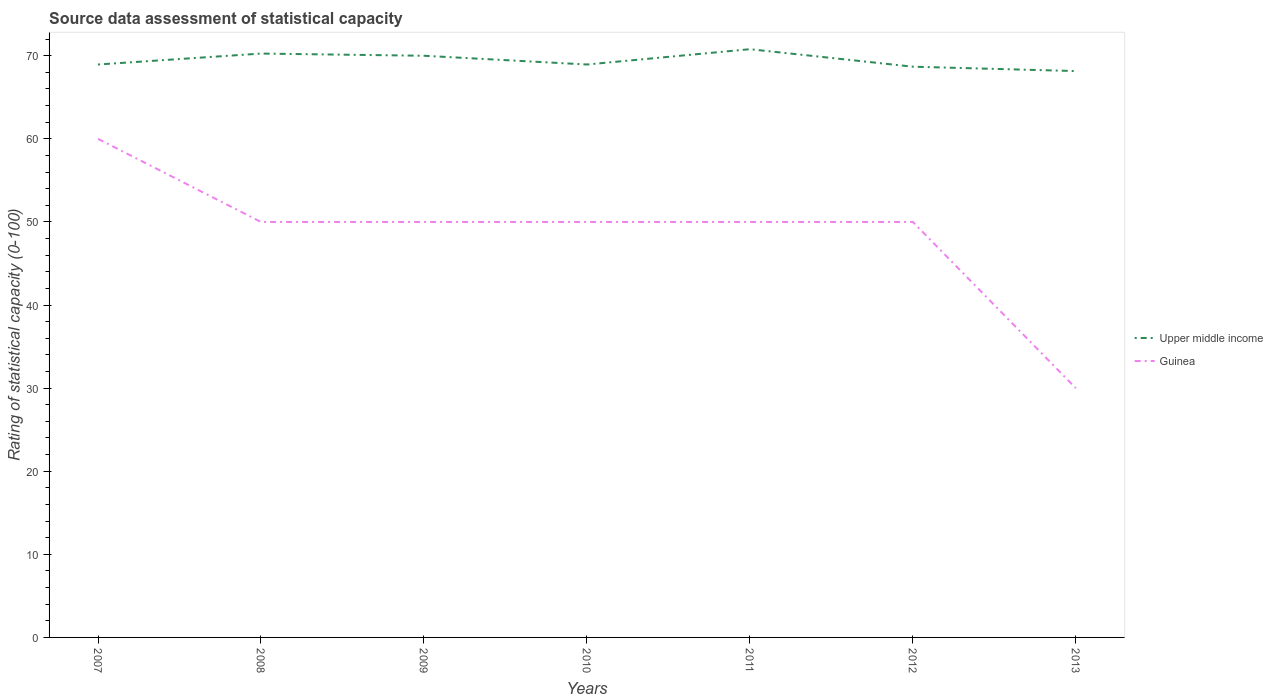How many different coloured lines are there?
Ensure brevity in your answer.  2. Does the line corresponding to Upper middle income intersect with the line corresponding to Guinea?
Keep it short and to the point. No. Is the number of lines equal to the number of legend labels?
Provide a succinct answer. Yes. Across all years, what is the maximum rating of statistical capacity in Upper middle income?
Give a very brief answer. 68.16. In which year was the rating of statistical capacity in Upper middle income maximum?
Offer a terse response. 2013. What is the total rating of statistical capacity in Upper middle income in the graph?
Offer a terse response. -1.84. What is the difference between the highest and the second highest rating of statistical capacity in Upper middle income?
Your answer should be compact. 2.63. Is the rating of statistical capacity in Guinea strictly greater than the rating of statistical capacity in Upper middle income over the years?
Your answer should be compact. Yes. How many lines are there?
Give a very brief answer. 2. How many years are there in the graph?
Your answer should be compact. 7. What is the difference between two consecutive major ticks on the Y-axis?
Your answer should be compact. 10. Are the values on the major ticks of Y-axis written in scientific E-notation?
Provide a succinct answer. No. Does the graph contain grids?
Give a very brief answer. No. How many legend labels are there?
Ensure brevity in your answer.  2. What is the title of the graph?
Provide a short and direct response. Source data assessment of statistical capacity. What is the label or title of the Y-axis?
Offer a very short reply. Rating of statistical capacity (0-100). What is the Rating of statistical capacity (0-100) in Upper middle income in 2007?
Offer a terse response. 68.95. What is the Rating of statistical capacity (0-100) of Guinea in 2007?
Make the answer very short. 60. What is the Rating of statistical capacity (0-100) of Upper middle income in 2008?
Provide a short and direct response. 70.26. What is the Rating of statistical capacity (0-100) in Upper middle income in 2009?
Provide a succinct answer. 70. What is the Rating of statistical capacity (0-100) of Guinea in 2009?
Your answer should be very brief. 50. What is the Rating of statistical capacity (0-100) of Upper middle income in 2010?
Provide a succinct answer. 68.95. What is the Rating of statistical capacity (0-100) of Upper middle income in 2011?
Offer a terse response. 70.79. What is the Rating of statistical capacity (0-100) in Upper middle income in 2012?
Give a very brief answer. 68.68. What is the Rating of statistical capacity (0-100) in Guinea in 2012?
Keep it short and to the point. 50. What is the Rating of statistical capacity (0-100) of Upper middle income in 2013?
Your answer should be compact. 68.16. What is the Rating of statistical capacity (0-100) of Guinea in 2013?
Keep it short and to the point. 30. Across all years, what is the maximum Rating of statistical capacity (0-100) of Upper middle income?
Provide a succinct answer. 70.79. Across all years, what is the maximum Rating of statistical capacity (0-100) in Guinea?
Make the answer very short. 60. Across all years, what is the minimum Rating of statistical capacity (0-100) in Upper middle income?
Make the answer very short. 68.16. Across all years, what is the minimum Rating of statistical capacity (0-100) in Guinea?
Offer a very short reply. 30. What is the total Rating of statistical capacity (0-100) of Upper middle income in the graph?
Offer a very short reply. 485.79. What is the total Rating of statistical capacity (0-100) of Guinea in the graph?
Offer a very short reply. 340. What is the difference between the Rating of statistical capacity (0-100) of Upper middle income in 2007 and that in 2008?
Your answer should be compact. -1.32. What is the difference between the Rating of statistical capacity (0-100) in Upper middle income in 2007 and that in 2009?
Your answer should be compact. -1.05. What is the difference between the Rating of statistical capacity (0-100) in Guinea in 2007 and that in 2009?
Keep it short and to the point. 10. What is the difference between the Rating of statistical capacity (0-100) in Guinea in 2007 and that in 2010?
Your response must be concise. 10. What is the difference between the Rating of statistical capacity (0-100) in Upper middle income in 2007 and that in 2011?
Your response must be concise. -1.84. What is the difference between the Rating of statistical capacity (0-100) in Upper middle income in 2007 and that in 2012?
Keep it short and to the point. 0.26. What is the difference between the Rating of statistical capacity (0-100) of Upper middle income in 2007 and that in 2013?
Your response must be concise. 0.79. What is the difference between the Rating of statistical capacity (0-100) of Guinea in 2007 and that in 2013?
Keep it short and to the point. 30. What is the difference between the Rating of statistical capacity (0-100) of Upper middle income in 2008 and that in 2009?
Give a very brief answer. 0.26. What is the difference between the Rating of statistical capacity (0-100) of Upper middle income in 2008 and that in 2010?
Ensure brevity in your answer.  1.32. What is the difference between the Rating of statistical capacity (0-100) in Upper middle income in 2008 and that in 2011?
Ensure brevity in your answer.  -0.53. What is the difference between the Rating of statistical capacity (0-100) in Guinea in 2008 and that in 2011?
Offer a terse response. 0. What is the difference between the Rating of statistical capacity (0-100) of Upper middle income in 2008 and that in 2012?
Ensure brevity in your answer.  1.58. What is the difference between the Rating of statistical capacity (0-100) in Upper middle income in 2008 and that in 2013?
Your answer should be compact. 2.11. What is the difference between the Rating of statistical capacity (0-100) in Guinea in 2008 and that in 2013?
Give a very brief answer. 20. What is the difference between the Rating of statistical capacity (0-100) in Upper middle income in 2009 and that in 2010?
Your answer should be very brief. 1.05. What is the difference between the Rating of statistical capacity (0-100) of Guinea in 2009 and that in 2010?
Offer a terse response. 0. What is the difference between the Rating of statistical capacity (0-100) of Upper middle income in 2009 and that in 2011?
Offer a very short reply. -0.79. What is the difference between the Rating of statistical capacity (0-100) of Upper middle income in 2009 and that in 2012?
Your answer should be very brief. 1.32. What is the difference between the Rating of statistical capacity (0-100) of Guinea in 2009 and that in 2012?
Provide a short and direct response. 0. What is the difference between the Rating of statistical capacity (0-100) of Upper middle income in 2009 and that in 2013?
Keep it short and to the point. 1.84. What is the difference between the Rating of statistical capacity (0-100) of Upper middle income in 2010 and that in 2011?
Your response must be concise. -1.84. What is the difference between the Rating of statistical capacity (0-100) in Guinea in 2010 and that in 2011?
Offer a very short reply. 0. What is the difference between the Rating of statistical capacity (0-100) in Upper middle income in 2010 and that in 2012?
Your answer should be very brief. 0.26. What is the difference between the Rating of statistical capacity (0-100) of Upper middle income in 2010 and that in 2013?
Provide a succinct answer. 0.79. What is the difference between the Rating of statistical capacity (0-100) of Upper middle income in 2011 and that in 2012?
Your answer should be compact. 2.11. What is the difference between the Rating of statistical capacity (0-100) in Guinea in 2011 and that in 2012?
Provide a short and direct response. 0. What is the difference between the Rating of statistical capacity (0-100) in Upper middle income in 2011 and that in 2013?
Ensure brevity in your answer.  2.63. What is the difference between the Rating of statistical capacity (0-100) of Upper middle income in 2012 and that in 2013?
Your response must be concise. 0.53. What is the difference between the Rating of statistical capacity (0-100) in Guinea in 2012 and that in 2013?
Keep it short and to the point. 20. What is the difference between the Rating of statistical capacity (0-100) in Upper middle income in 2007 and the Rating of statistical capacity (0-100) in Guinea in 2008?
Make the answer very short. 18.95. What is the difference between the Rating of statistical capacity (0-100) in Upper middle income in 2007 and the Rating of statistical capacity (0-100) in Guinea in 2009?
Provide a short and direct response. 18.95. What is the difference between the Rating of statistical capacity (0-100) of Upper middle income in 2007 and the Rating of statistical capacity (0-100) of Guinea in 2010?
Offer a terse response. 18.95. What is the difference between the Rating of statistical capacity (0-100) of Upper middle income in 2007 and the Rating of statistical capacity (0-100) of Guinea in 2011?
Offer a very short reply. 18.95. What is the difference between the Rating of statistical capacity (0-100) of Upper middle income in 2007 and the Rating of statistical capacity (0-100) of Guinea in 2012?
Your answer should be compact. 18.95. What is the difference between the Rating of statistical capacity (0-100) of Upper middle income in 2007 and the Rating of statistical capacity (0-100) of Guinea in 2013?
Offer a terse response. 38.95. What is the difference between the Rating of statistical capacity (0-100) of Upper middle income in 2008 and the Rating of statistical capacity (0-100) of Guinea in 2009?
Provide a succinct answer. 20.26. What is the difference between the Rating of statistical capacity (0-100) of Upper middle income in 2008 and the Rating of statistical capacity (0-100) of Guinea in 2010?
Offer a very short reply. 20.26. What is the difference between the Rating of statistical capacity (0-100) in Upper middle income in 2008 and the Rating of statistical capacity (0-100) in Guinea in 2011?
Your answer should be very brief. 20.26. What is the difference between the Rating of statistical capacity (0-100) of Upper middle income in 2008 and the Rating of statistical capacity (0-100) of Guinea in 2012?
Your response must be concise. 20.26. What is the difference between the Rating of statistical capacity (0-100) in Upper middle income in 2008 and the Rating of statistical capacity (0-100) in Guinea in 2013?
Give a very brief answer. 40.26. What is the difference between the Rating of statistical capacity (0-100) in Upper middle income in 2009 and the Rating of statistical capacity (0-100) in Guinea in 2011?
Your answer should be very brief. 20. What is the difference between the Rating of statistical capacity (0-100) of Upper middle income in 2009 and the Rating of statistical capacity (0-100) of Guinea in 2012?
Your answer should be very brief. 20. What is the difference between the Rating of statistical capacity (0-100) in Upper middle income in 2009 and the Rating of statistical capacity (0-100) in Guinea in 2013?
Your response must be concise. 40. What is the difference between the Rating of statistical capacity (0-100) in Upper middle income in 2010 and the Rating of statistical capacity (0-100) in Guinea in 2011?
Ensure brevity in your answer.  18.95. What is the difference between the Rating of statistical capacity (0-100) of Upper middle income in 2010 and the Rating of statistical capacity (0-100) of Guinea in 2012?
Provide a short and direct response. 18.95. What is the difference between the Rating of statistical capacity (0-100) of Upper middle income in 2010 and the Rating of statistical capacity (0-100) of Guinea in 2013?
Make the answer very short. 38.95. What is the difference between the Rating of statistical capacity (0-100) of Upper middle income in 2011 and the Rating of statistical capacity (0-100) of Guinea in 2012?
Offer a very short reply. 20.79. What is the difference between the Rating of statistical capacity (0-100) of Upper middle income in 2011 and the Rating of statistical capacity (0-100) of Guinea in 2013?
Your answer should be very brief. 40.79. What is the difference between the Rating of statistical capacity (0-100) in Upper middle income in 2012 and the Rating of statistical capacity (0-100) in Guinea in 2013?
Your answer should be very brief. 38.68. What is the average Rating of statistical capacity (0-100) in Upper middle income per year?
Give a very brief answer. 69.4. What is the average Rating of statistical capacity (0-100) of Guinea per year?
Provide a succinct answer. 48.57. In the year 2007, what is the difference between the Rating of statistical capacity (0-100) in Upper middle income and Rating of statistical capacity (0-100) in Guinea?
Offer a very short reply. 8.95. In the year 2008, what is the difference between the Rating of statistical capacity (0-100) in Upper middle income and Rating of statistical capacity (0-100) in Guinea?
Give a very brief answer. 20.26. In the year 2009, what is the difference between the Rating of statistical capacity (0-100) in Upper middle income and Rating of statistical capacity (0-100) in Guinea?
Offer a very short reply. 20. In the year 2010, what is the difference between the Rating of statistical capacity (0-100) in Upper middle income and Rating of statistical capacity (0-100) in Guinea?
Provide a succinct answer. 18.95. In the year 2011, what is the difference between the Rating of statistical capacity (0-100) in Upper middle income and Rating of statistical capacity (0-100) in Guinea?
Your response must be concise. 20.79. In the year 2012, what is the difference between the Rating of statistical capacity (0-100) of Upper middle income and Rating of statistical capacity (0-100) of Guinea?
Provide a succinct answer. 18.68. In the year 2013, what is the difference between the Rating of statistical capacity (0-100) in Upper middle income and Rating of statistical capacity (0-100) in Guinea?
Ensure brevity in your answer.  38.16. What is the ratio of the Rating of statistical capacity (0-100) of Upper middle income in 2007 to that in 2008?
Offer a terse response. 0.98. What is the ratio of the Rating of statistical capacity (0-100) of Guinea in 2007 to that in 2008?
Offer a very short reply. 1.2. What is the ratio of the Rating of statistical capacity (0-100) of Upper middle income in 2007 to that in 2009?
Offer a terse response. 0.98. What is the ratio of the Rating of statistical capacity (0-100) of Guinea in 2007 to that in 2009?
Your response must be concise. 1.2. What is the ratio of the Rating of statistical capacity (0-100) of Guinea in 2007 to that in 2010?
Your answer should be very brief. 1.2. What is the ratio of the Rating of statistical capacity (0-100) in Upper middle income in 2007 to that in 2011?
Ensure brevity in your answer.  0.97. What is the ratio of the Rating of statistical capacity (0-100) of Guinea in 2007 to that in 2012?
Your answer should be compact. 1.2. What is the ratio of the Rating of statistical capacity (0-100) of Upper middle income in 2007 to that in 2013?
Give a very brief answer. 1.01. What is the ratio of the Rating of statistical capacity (0-100) of Guinea in 2007 to that in 2013?
Your response must be concise. 2. What is the ratio of the Rating of statistical capacity (0-100) in Upper middle income in 2008 to that in 2010?
Your response must be concise. 1.02. What is the ratio of the Rating of statistical capacity (0-100) of Upper middle income in 2008 to that in 2011?
Make the answer very short. 0.99. What is the ratio of the Rating of statistical capacity (0-100) in Upper middle income in 2008 to that in 2013?
Keep it short and to the point. 1.03. What is the ratio of the Rating of statistical capacity (0-100) of Upper middle income in 2009 to that in 2010?
Ensure brevity in your answer.  1.02. What is the ratio of the Rating of statistical capacity (0-100) of Guinea in 2009 to that in 2010?
Provide a succinct answer. 1. What is the ratio of the Rating of statistical capacity (0-100) of Guinea in 2009 to that in 2011?
Provide a succinct answer. 1. What is the ratio of the Rating of statistical capacity (0-100) of Upper middle income in 2009 to that in 2012?
Offer a terse response. 1.02. What is the ratio of the Rating of statistical capacity (0-100) in Upper middle income in 2009 to that in 2013?
Your response must be concise. 1.03. What is the ratio of the Rating of statistical capacity (0-100) of Guinea in 2009 to that in 2013?
Your response must be concise. 1.67. What is the ratio of the Rating of statistical capacity (0-100) in Upper middle income in 2010 to that in 2012?
Keep it short and to the point. 1. What is the ratio of the Rating of statistical capacity (0-100) of Upper middle income in 2010 to that in 2013?
Offer a terse response. 1.01. What is the ratio of the Rating of statistical capacity (0-100) of Upper middle income in 2011 to that in 2012?
Your answer should be very brief. 1.03. What is the ratio of the Rating of statistical capacity (0-100) in Guinea in 2011 to that in 2012?
Give a very brief answer. 1. What is the ratio of the Rating of statistical capacity (0-100) of Upper middle income in 2011 to that in 2013?
Provide a short and direct response. 1.04. What is the ratio of the Rating of statistical capacity (0-100) of Upper middle income in 2012 to that in 2013?
Your answer should be compact. 1.01. What is the ratio of the Rating of statistical capacity (0-100) of Guinea in 2012 to that in 2013?
Make the answer very short. 1.67. What is the difference between the highest and the second highest Rating of statistical capacity (0-100) in Upper middle income?
Ensure brevity in your answer.  0.53. What is the difference between the highest and the second highest Rating of statistical capacity (0-100) of Guinea?
Your answer should be compact. 10. What is the difference between the highest and the lowest Rating of statistical capacity (0-100) in Upper middle income?
Provide a short and direct response. 2.63. What is the difference between the highest and the lowest Rating of statistical capacity (0-100) in Guinea?
Provide a succinct answer. 30. 